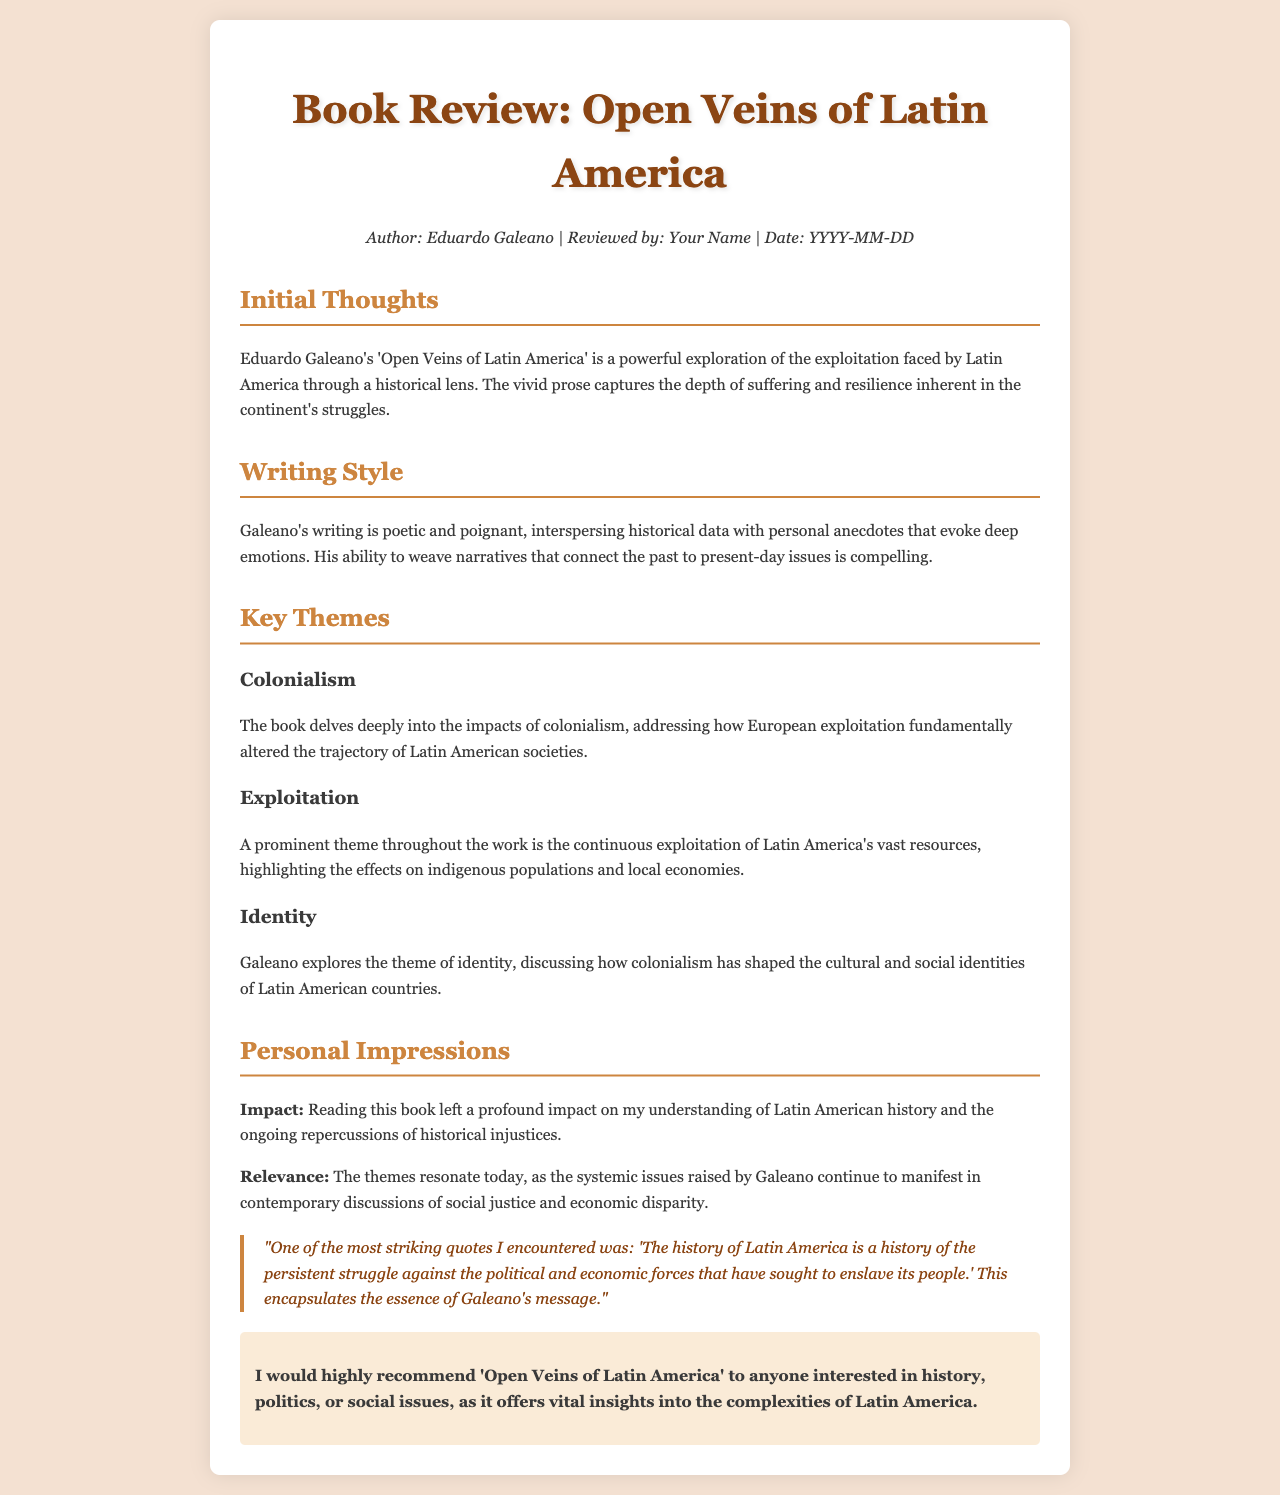What is the title of the book? The title is mentioned prominently in the document as the main focus of the review.
Answer: Open Veins of Latin America Who is the author of the book? The author is specified in the meta section of the document, which typically includes the author's name.
Answer: Eduardo Galeano What is one of the key themes discussed? The review mentions several key themes under the section titled "Key Themes".
Answer: Colonialism What impact did reading this book have? The personal impressions section details the reader's feelings about the book's influence.
Answer: Profound impact What is the recommendation made in the review? The document includes a section that emphasizes the reviewer’s recommendation for the book.
Answer: Highly recommend What date is mentioned in the meta section? The meta section usually states the review date, used for informational context.
Answer: YYYY-MM-DD Which writing style is attributed to Galeano? The review discusses Galeano’s style in the writing style section.
Answer: Poetic and poignant What quote marked the review's essence? A quote from the document encapsulates Galeano's message, highlighted in bold.
Answer: "The history of Latin America is a history of the persistent struggle against the political and economic forces that have sought to enslave its people." In which section are the initial thoughts presented? Initial thoughts are discussed in the first thematic section following the title.
Answer: Initial Thoughts 